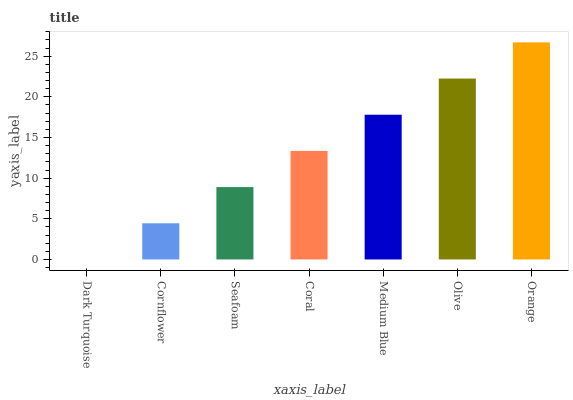Is Dark Turquoise the minimum?
Answer yes or no. Yes. Is Orange the maximum?
Answer yes or no. Yes. Is Cornflower the minimum?
Answer yes or no. No. Is Cornflower the maximum?
Answer yes or no. No. Is Cornflower greater than Dark Turquoise?
Answer yes or no. Yes. Is Dark Turquoise less than Cornflower?
Answer yes or no. Yes. Is Dark Turquoise greater than Cornflower?
Answer yes or no. No. Is Cornflower less than Dark Turquoise?
Answer yes or no. No. Is Coral the high median?
Answer yes or no. Yes. Is Coral the low median?
Answer yes or no. Yes. Is Medium Blue the high median?
Answer yes or no. No. Is Orange the low median?
Answer yes or no. No. 